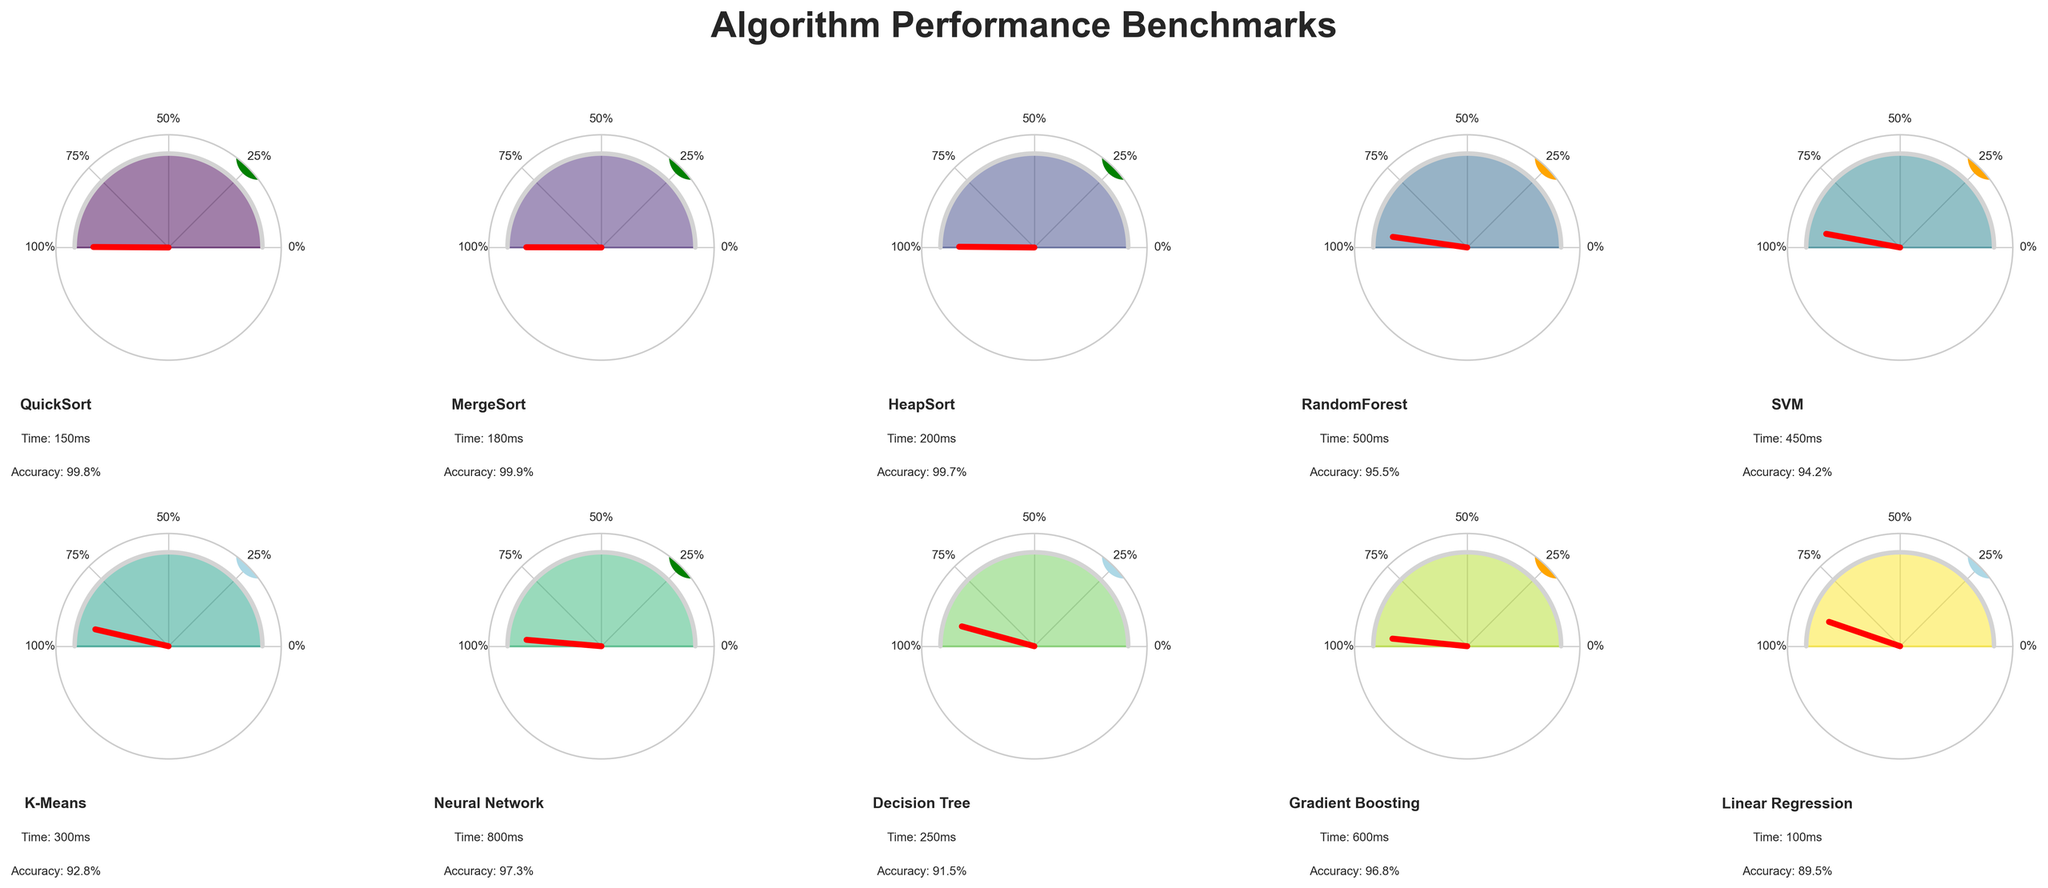What is the execution time of the QuickSort algorithm? The execution time is listed below the name of each algorithm on the gauge chart. By looking at the corresponding panel for QuickSort, you can see that the execution time is 150 milliseconds.
Answer: 150 milliseconds Which algorithm has the highest accuracy? Accuracy is indicated by the red needle on the gauge charts. By comparing the needle positions across all panels, the MergeSort algorithm has the highest accuracy with an accuracy indicator at 99.9%.
Answer: MergeSort What is the dataset size for the Neural Network algorithm? The dataset size is represented by a colored circle in each panel. For the Neural Network panel, the color of the circle is green, which corresponds to a large dataset.
Answer: Large Which algorithm has a longer execution time, RandomForest or SVM? Referring to the execution times listed in each gauge chart, RandomForest has an execution time of 500 milliseconds, and SVM has an execution time of 450 milliseconds. Therefore, RandomForest has a longer execution time.
Answer: RandomForest What is the average accuracy of the algorithms that use a medium dataset size? The average accuracy is calculated using the accuracies of algorithms with medium dataset sizes: RandomForest (95.5%), SVM (94.2%), and Gradient Boosting (96.8%). The average accuracy is (95.5 + 94.2 + 96.8)/3 = 95.5%.
Answer: 95.5% Which algorithm is represented by an orange circle and what does that color indicate? The color orange represents a medium dataset size. By identifying the panel with an orange circle, you can see that it corresponds to the RandomForest algorithm.
Answer: RandomForest, Medium Between QuickSort and Linear Regression, which algorithm has higher execution time and by how much? The execution times are 150 milliseconds for QuickSort and 100 milliseconds for Linear Regression. The difference is 150 - 100 = 50 milliseconds.
Answer: QuickSort, 50 milliseconds What is the combined execution time of the three algorithms with the highest execution times? Identifying the three algorithms with the highest execution times: Neural Network (800 milliseconds), Gradient Boosting (600 milliseconds), and RandomForest (500 milliseconds). The combined execution time is 800 + 600 + 500 = 1900 milliseconds.
Answer: 1900 milliseconds Which algorithm has the lowest accuracy, and what is its accuracy percentage? By looking at the position of the red needles on each gauge chart, the Decision Tree algorithm has the lowest accuracy at 91.5%.
Answer: Decision Tree, 91.5% 